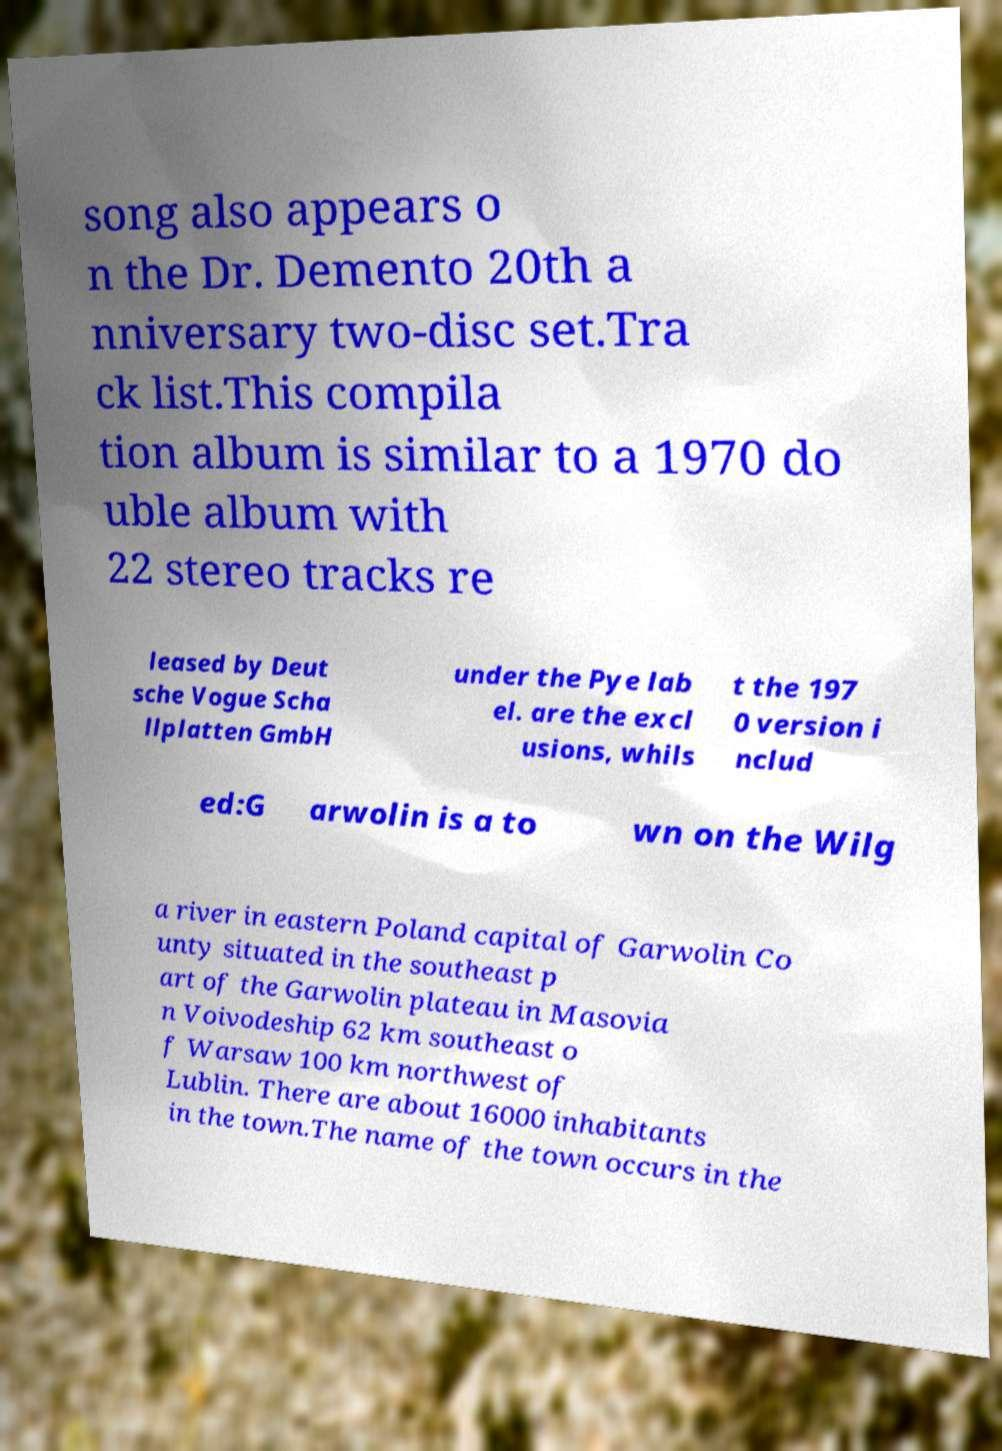Could you extract and type out the text from this image? song also appears o n the Dr. Demento 20th a nniversary two-disc set.Tra ck list.This compila tion album is similar to a 1970 do uble album with 22 stereo tracks re leased by Deut sche Vogue Scha llplatten GmbH under the Pye lab el. are the excl usions, whils t the 197 0 version i nclud ed:G arwolin is a to wn on the Wilg a river in eastern Poland capital of Garwolin Co unty situated in the southeast p art of the Garwolin plateau in Masovia n Voivodeship 62 km southeast o f Warsaw 100 km northwest of Lublin. There are about 16000 inhabitants in the town.The name of the town occurs in the 